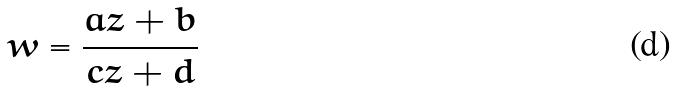<formula> <loc_0><loc_0><loc_500><loc_500>w = \frac { a z + b } { c z + d }</formula> 